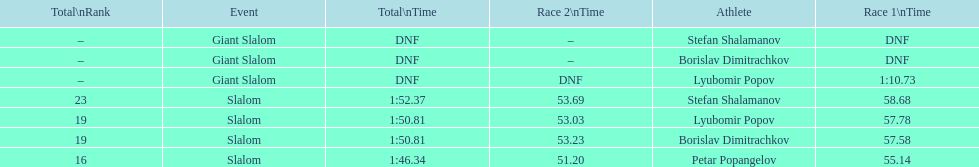Could you parse the entire table as a dict? {'header': ['Total\\nRank', 'Event', 'Total\\nTime', 'Race 2\\nTime', 'Athlete', 'Race 1\\nTime'], 'rows': [['–', 'Giant Slalom', 'DNF', '–', 'Stefan Shalamanov', 'DNF'], ['–', 'Giant Slalom', 'DNF', '–', 'Borislav Dimitrachkov', 'DNF'], ['–', 'Giant Slalom', 'DNF', 'DNF', 'Lyubomir Popov', '1:10.73'], ['23', 'Slalom', '1:52.37', '53.69', 'Stefan Shalamanov', '58.68'], ['19', 'Slalom', '1:50.81', '53.03', 'Lyubomir Popov', '57.78'], ['19', 'Slalom', '1:50.81', '53.23', 'Borislav Dimitrachkov', '57.58'], ['16', 'Slalom', '1:46.34', '51.20', 'Petar Popangelov', '55.14']]} Who possesses the greatest ranking? Petar Popangelov. 